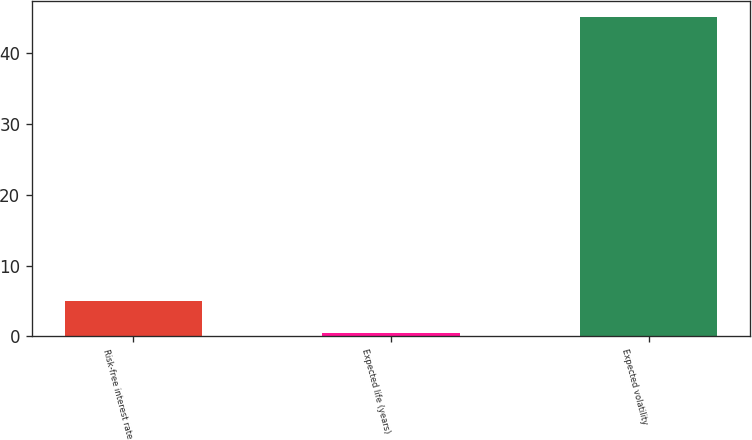Convert chart. <chart><loc_0><loc_0><loc_500><loc_500><bar_chart><fcel>Risk-free interest rate<fcel>Expected life (years)<fcel>Expected volatility<nl><fcel>4.97<fcel>0.5<fcel>45.2<nl></chart> 